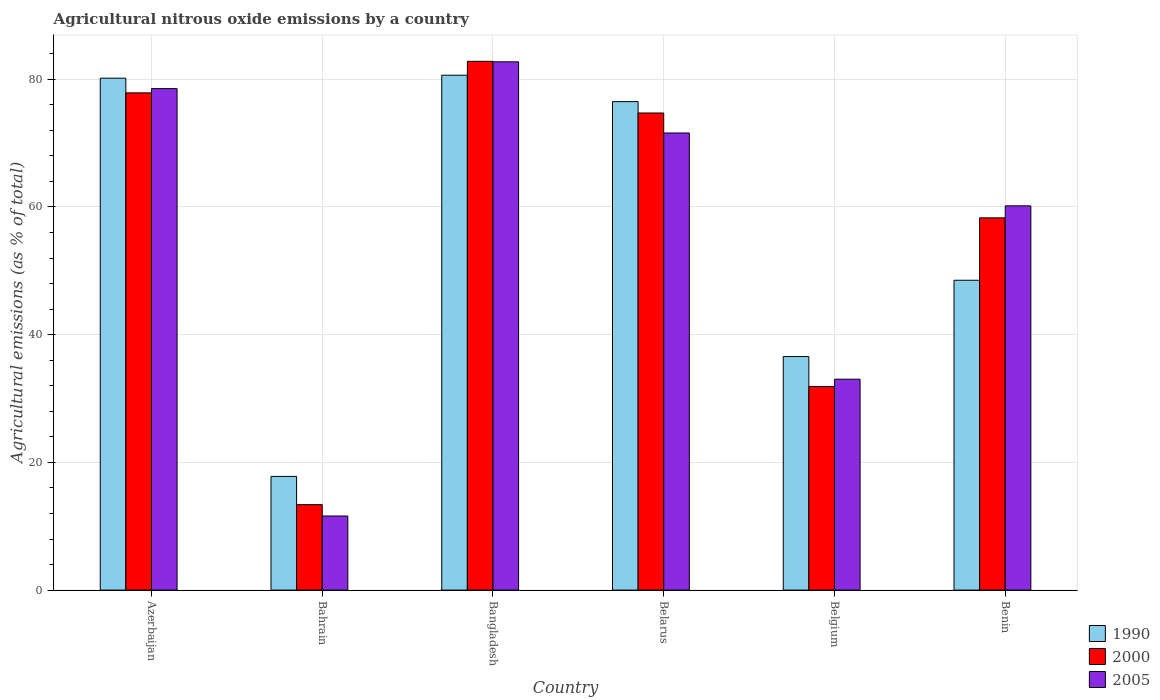How many groups of bars are there?
Make the answer very short. 6. Are the number of bars per tick equal to the number of legend labels?
Your answer should be compact. Yes. How many bars are there on the 3rd tick from the left?
Offer a very short reply. 3. How many bars are there on the 6th tick from the right?
Offer a terse response. 3. What is the label of the 4th group of bars from the left?
Make the answer very short. Belarus. What is the amount of agricultural nitrous oxide emitted in 1990 in Belgium?
Your answer should be compact. 36.57. Across all countries, what is the maximum amount of agricultural nitrous oxide emitted in 2000?
Make the answer very short. 82.81. Across all countries, what is the minimum amount of agricultural nitrous oxide emitted in 2005?
Offer a very short reply. 11.6. In which country was the amount of agricultural nitrous oxide emitted in 1990 maximum?
Make the answer very short. Bangladesh. In which country was the amount of agricultural nitrous oxide emitted in 2000 minimum?
Your answer should be very brief. Bahrain. What is the total amount of agricultural nitrous oxide emitted in 1990 in the graph?
Make the answer very short. 340.2. What is the difference between the amount of agricultural nitrous oxide emitted in 2005 in Bangladesh and that in Benin?
Offer a terse response. 22.55. What is the difference between the amount of agricultural nitrous oxide emitted in 1990 in Benin and the amount of agricultural nitrous oxide emitted in 2000 in Azerbaijan?
Make the answer very short. -29.35. What is the average amount of agricultural nitrous oxide emitted in 2005 per country?
Offer a terse response. 56.28. What is the difference between the amount of agricultural nitrous oxide emitted of/in 2000 and amount of agricultural nitrous oxide emitted of/in 1990 in Benin?
Your response must be concise. 9.77. What is the ratio of the amount of agricultural nitrous oxide emitted in 1990 in Bahrain to that in Belgium?
Offer a terse response. 0.49. Is the amount of agricultural nitrous oxide emitted in 2000 in Belarus less than that in Benin?
Provide a succinct answer. No. Is the difference between the amount of agricultural nitrous oxide emitted in 2000 in Azerbaijan and Benin greater than the difference between the amount of agricultural nitrous oxide emitted in 1990 in Azerbaijan and Benin?
Your response must be concise. No. What is the difference between the highest and the second highest amount of agricultural nitrous oxide emitted in 2000?
Your answer should be compact. 4.94. What is the difference between the highest and the lowest amount of agricultural nitrous oxide emitted in 1990?
Provide a short and direct response. 62.83. What does the 3rd bar from the left in Azerbaijan represents?
Provide a short and direct response. 2005. What does the 2nd bar from the right in Belgium represents?
Give a very brief answer. 2000. Are all the bars in the graph horizontal?
Keep it short and to the point. No. Are the values on the major ticks of Y-axis written in scientific E-notation?
Provide a succinct answer. No. Does the graph contain any zero values?
Provide a succinct answer. No. How are the legend labels stacked?
Provide a short and direct response. Vertical. What is the title of the graph?
Provide a short and direct response. Agricultural nitrous oxide emissions by a country. Does "1994" appear as one of the legend labels in the graph?
Ensure brevity in your answer.  No. What is the label or title of the X-axis?
Provide a short and direct response. Country. What is the label or title of the Y-axis?
Provide a succinct answer. Agricultural emissions (as % of total). What is the Agricultural emissions (as % of total) in 1990 in Azerbaijan?
Your response must be concise. 80.17. What is the Agricultural emissions (as % of total) of 2000 in Azerbaijan?
Offer a very short reply. 77.87. What is the Agricultural emissions (as % of total) in 2005 in Azerbaijan?
Your response must be concise. 78.53. What is the Agricultural emissions (as % of total) of 1990 in Bahrain?
Offer a very short reply. 17.81. What is the Agricultural emissions (as % of total) in 2000 in Bahrain?
Keep it short and to the point. 13.38. What is the Agricultural emissions (as % of total) of 2005 in Bahrain?
Give a very brief answer. 11.6. What is the Agricultural emissions (as % of total) in 1990 in Bangladesh?
Your answer should be compact. 80.63. What is the Agricultural emissions (as % of total) of 2000 in Bangladesh?
Your answer should be very brief. 82.81. What is the Agricultural emissions (as % of total) in 2005 in Bangladesh?
Provide a short and direct response. 82.73. What is the Agricultural emissions (as % of total) of 1990 in Belarus?
Your answer should be compact. 76.5. What is the Agricultural emissions (as % of total) in 2000 in Belarus?
Your answer should be very brief. 74.72. What is the Agricultural emissions (as % of total) of 2005 in Belarus?
Provide a short and direct response. 71.59. What is the Agricultural emissions (as % of total) in 1990 in Belgium?
Your response must be concise. 36.57. What is the Agricultural emissions (as % of total) in 2000 in Belgium?
Keep it short and to the point. 31.88. What is the Agricultural emissions (as % of total) of 2005 in Belgium?
Make the answer very short. 33.03. What is the Agricultural emissions (as % of total) in 1990 in Benin?
Your response must be concise. 48.52. What is the Agricultural emissions (as % of total) in 2000 in Benin?
Your answer should be compact. 58.3. What is the Agricultural emissions (as % of total) of 2005 in Benin?
Make the answer very short. 60.18. Across all countries, what is the maximum Agricultural emissions (as % of total) in 1990?
Keep it short and to the point. 80.63. Across all countries, what is the maximum Agricultural emissions (as % of total) in 2000?
Your answer should be very brief. 82.81. Across all countries, what is the maximum Agricultural emissions (as % of total) in 2005?
Offer a terse response. 82.73. Across all countries, what is the minimum Agricultural emissions (as % of total) in 1990?
Keep it short and to the point. 17.81. Across all countries, what is the minimum Agricultural emissions (as % of total) in 2000?
Make the answer very short. 13.38. Across all countries, what is the minimum Agricultural emissions (as % of total) in 2005?
Make the answer very short. 11.6. What is the total Agricultural emissions (as % of total) of 1990 in the graph?
Offer a very short reply. 340.2. What is the total Agricultural emissions (as % of total) of 2000 in the graph?
Provide a succinct answer. 338.95. What is the total Agricultural emissions (as % of total) of 2005 in the graph?
Your response must be concise. 337.66. What is the difference between the Agricultural emissions (as % of total) in 1990 in Azerbaijan and that in Bahrain?
Your answer should be compact. 62.36. What is the difference between the Agricultural emissions (as % of total) in 2000 in Azerbaijan and that in Bahrain?
Make the answer very short. 64.49. What is the difference between the Agricultural emissions (as % of total) of 2005 in Azerbaijan and that in Bahrain?
Your answer should be very brief. 66.93. What is the difference between the Agricultural emissions (as % of total) in 1990 in Azerbaijan and that in Bangladesh?
Your response must be concise. -0.47. What is the difference between the Agricultural emissions (as % of total) in 2000 in Azerbaijan and that in Bangladesh?
Offer a very short reply. -4.94. What is the difference between the Agricultural emissions (as % of total) of 2005 in Azerbaijan and that in Bangladesh?
Keep it short and to the point. -4.2. What is the difference between the Agricultural emissions (as % of total) of 1990 in Azerbaijan and that in Belarus?
Ensure brevity in your answer.  3.67. What is the difference between the Agricultural emissions (as % of total) in 2000 in Azerbaijan and that in Belarus?
Make the answer very short. 3.16. What is the difference between the Agricultural emissions (as % of total) of 2005 in Azerbaijan and that in Belarus?
Give a very brief answer. 6.94. What is the difference between the Agricultural emissions (as % of total) of 1990 in Azerbaijan and that in Belgium?
Offer a very short reply. 43.59. What is the difference between the Agricultural emissions (as % of total) of 2000 in Azerbaijan and that in Belgium?
Your response must be concise. 45.99. What is the difference between the Agricultural emissions (as % of total) of 2005 in Azerbaijan and that in Belgium?
Provide a short and direct response. 45.5. What is the difference between the Agricultural emissions (as % of total) in 1990 in Azerbaijan and that in Benin?
Keep it short and to the point. 31.64. What is the difference between the Agricultural emissions (as % of total) in 2000 in Azerbaijan and that in Benin?
Keep it short and to the point. 19.57. What is the difference between the Agricultural emissions (as % of total) in 2005 in Azerbaijan and that in Benin?
Ensure brevity in your answer.  18.35. What is the difference between the Agricultural emissions (as % of total) of 1990 in Bahrain and that in Bangladesh?
Your response must be concise. -62.83. What is the difference between the Agricultural emissions (as % of total) of 2000 in Bahrain and that in Bangladesh?
Give a very brief answer. -69.43. What is the difference between the Agricultural emissions (as % of total) in 2005 in Bahrain and that in Bangladesh?
Your answer should be very brief. -71.13. What is the difference between the Agricultural emissions (as % of total) in 1990 in Bahrain and that in Belarus?
Ensure brevity in your answer.  -58.69. What is the difference between the Agricultural emissions (as % of total) of 2000 in Bahrain and that in Belarus?
Ensure brevity in your answer.  -61.34. What is the difference between the Agricultural emissions (as % of total) in 2005 in Bahrain and that in Belarus?
Offer a very short reply. -59.98. What is the difference between the Agricultural emissions (as % of total) of 1990 in Bahrain and that in Belgium?
Make the answer very short. -18.77. What is the difference between the Agricultural emissions (as % of total) of 2000 in Bahrain and that in Belgium?
Provide a short and direct response. -18.5. What is the difference between the Agricultural emissions (as % of total) in 2005 in Bahrain and that in Belgium?
Offer a terse response. -21.43. What is the difference between the Agricultural emissions (as % of total) of 1990 in Bahrain and that in Benin?
Your response must be concise. -30.72. What is the difference between the Agricultural emissions (as % of total) of 2000 in Bahrain and that in Benin?
Offer a very short reply. -44.92. What is the difference between the Agricultural emissions (as % of total) in 2005 in Bahrain and that in Benin?
Ensure brevity in your answer.  -48.57. What is the difference between the Agricultural emissions (as % of total) of 1990 in Bangladesh and that in Belarus?
Give a very brief answer. 4.13. What is the difference between the Agricultural emissions (as % of total) in 2000 in Bangladesh and that in Belarus?
Ensure brevity in your answer.  8.09. What is the difference between the Agricultural emissions (as % of total) of 2005 in Bangladesh and that in Belarus?
Keep it short and to the point. 11.14. What is the difference between the Agricultural emissions (as % of total) of 1990 in Bangladesh and that in Belgium?
Provide a short and direct response. 44.06. What is the difference between the Agricultural emissions (as % of total) in 2000 in Bangladesh and that in Belgium?
Give a very brief answer. 50.93. What is the difference between the Agricultural emissions (as % of total) in 2005 in Bangladesh and that in Belgium?
Give a very brief answer. 49.7. What is the difference between the Agricultural emissions (as % of total) of 1990 in Bangladesh and that in Benin?
Your answer should be very brief. 32.11. What is the difference between the Agricultural emissions (as % of total) in 2000 in Bangladesh and that in Benin?
Make the answer very short. 24.51. What is the difference between the Agricultural emissions (as % of total) in 2005 in Bangladesh and that in Benin?
Keep it short and to the point. 22.55. What is the difference between the Agricultural emissions (as % of total) of 1990 in Belarus and that in Belgium?
Offer a very short reply. 39.93. What is the difference between the Agricultural emissions (as % of total) in 2000 in Belarus and that in Belgium?
Your answer should be compact. 42.83. What is the difference between the Agricultural emissions (as % of total) of 2005 in Belarus and that in Belgium?
Give a very brief answer. 38.56. What is the difference between the Agricultural emissions (as % of total) in 1990 in Belarus and that in Benin?
Your answer should be compact. 27.98. What is the difference between the Agricultural emissions (as % of total) in 2000 in Belarus and that in Benin?
Offer a very short reply. 16.42. What is the difference between the Agricultural emissions (as % of total) of 2005 in Belarus and that in Benin?
Ensure brevity in your answer.  11.41. What is the difference between the Agricultural emissions (as % of total) of 1990 in Belgium and that in Benin?
Your response must be concise. -11.95. What is the difference between the Agricultural emissions (as % of total) of 2000 in Belgium and that in Benin?
Make the answer very short. -26.42. What is the difference between the Agricultural emissions (as % of total) of 2005 in Belgium and that in Benin?
Make the answer very short. -27.15. What is the difference between the Agricultural emissions (as % of total) of 1990 in Azerbaijan and the Agricultural emissions (as % of total) of 2000 in Bahrain?
Keep it short and to the point. 66.79. What is the difference between the Agricultural emissions (as % of total) in 1990 in Azerbaijan and the Agricultural emissions (as % of total) in 2005 in Bahrain?
Your answer should be very brief. 68.56. What is the difference between the Agricultural emissions (as % of total) in 2000 in Azerbaijan and the Agricultural emissions (as % of total) in 2005 in Bahrain?
Your answer should be compact. 66.27. What is the difference between the Agricultural emissions (as % of total) of 1990 in Azerbaijan and the Agricultural emissions (as % of total) of 2000 in Bangladesh?
Give a very brief answer. -2.64. What is the difference between the Agricultural emissions (as % of total) in 1990 in Azerbaijan and the Agricultural emissions (as % of total) in 2005 in Bangladesh?
Offer a very short reply. -2.56. What is the difference between the Agricultural emissions (as % of total) in 2000 in Azerbaijan and the Agricultural emissions (as % of total) in 2005 in Bangladesh?
Offer a terse response. -4.86. What is the difference between the Agricultural emissions (as % of total) of 1990 in Azerbaijan and the Agricultural emissions (as % of total) of 2000 in Belarus?
Your answer should be very brief. 5.45. What is the difference between the Agricultural emissions (as % of total) of 1990 in Azerbaijan and the Agricultural emissions (as % of total) of 2005 in Belarus?
Offer a very short reply. 8.58. What is the difference between the Agricultural emissions (as % of total) of 2000 in Azerbaijan and the Agricultural emissions (as % of total) of 2005 in Belarus?
Provide a succinct answer. 6.28. What is the difference between the Agricultural emissions (as % of total) of 1990 in Azerbaijan and the Agricultural emissions (as % of total) of 2000 in Belgium?
Offer a terse response. 48.29. What is the difference between the Agricultural emissions (as % of total) of 1990 in Azerbaijan and the Agricultural emissions (as % of total) of 2005 in Belgium?
Provide a succinct answer. 47.14. What is the difference between the Agricultural emissions (as % of total) of 2000 in Azerbaijan and the Agricultural emissions (as % of total) of 2005 in Belgium?
Make the answer very short. 44.84. What is the difference between the Agricultural emissions (as % of total) of 1990 in Azerbaijan and the Agricultural emissions (as % of total) of 2000 in Benin?
Give a very brief answer. 21.87. What is the difference between the Agricultural emissions (as % of total) of 1990 in Azerbaijan and the Agricultural emissions (as % of total) of 2005 in Benin?
Your response must be concise. 19.99. What is the difference between the Agricultural emissions (as % of total) in 2000 in Azerbaijan and the Agricultural emissions (as % of total) in 2005 in Benin?
Provide a short and direct response. 17.69. What is the difference between the Agricultural emissions (as % of total) of 1990 in Bahrain and the Agricultural emissions (as % of total) of 2000 in Bangladesh?
Your response must be concise. -65. What is the difference between the Agricultural emissions (as % of total) of 1990 in Bahrain and the Agricultural emissions (as % of total) of 2005 in Bangladesh?
Offer a very short reply. -64.92. What is the difference between the Agricultural emissions (as % of total) in 2000 in Bahrain and the Agricultural emissions (as % of total) in 2005 in Bangladesh?
Provide a short and direct response. -69.35. What is the difference between the Agricultural emissions (as % of total) in 1990 in Bahrain and the Agricultural emissions (as % of total) in 2000 in Belarus?
Ensure brevity in your answer.  -56.91. What is the difference between the Agricultural emissions (as % of total) of 1990 in Bahrain and the Agricultural emissions (as % of total) of 2005 in Belarus?
Keep it short and to the point. -53.78. What is the difference between the Agricultural emissions (as % of total) in 2000 in Bahrain and the Agricultural emissions (as % of total) in 2005 in Belarus?
Your response must be concise. -58.21. What is the difference between the Agricultural emissions (as % of total) of 1990 in Bahrain and the Agricultural emissions (as % of total) of 2000 in Belgium?
Make the answer very short. -14.07. What is the difference between the Agricultural emissions (as % of total) of 1990 in Bahrain and the Agricultural emissions (as % of total) of 2005 in Belgium?
Provide a short and direct response. -15.22. What is the difference between the Agricultural emissions (as % of total) of 2000 in Bahrain and the Agricultural emissions (as % of total) of 2005 in Belgium?
Give a very brief answer. -19.65. What is the difference between the Agricultural emissions (as % of total) in 1990 in Bahrain and the Agricultural emissions (as % of total) in 2000 in Benin?
Your answer should be compact. -40.49. What is the difference between the Agricultural emissions (as % of total) of 1990 in Bahrain and the Agricultural emissions (as % of total) of 2005 in Benin?
Provide a short and direct response. -42.37. What is the difference between the Agricultural emissions (as % of total) in 2000 in Bahrain and the Agricultural emissions (as % of total) in 2005 in Benin?
Your answer should be compact. -46.8. What is the difference between the Agricultural emissions (as % of total) in 1990 in Bangladesh and the Agricultural emissions (as % of total) in 2000 in Belarus?
Offer a terse response. 5.92. What is the difference between the Agricultural emissions (as % of total) of 1990 in Bangladesh and the Agricultural emissions (as % of total) of 2005 in Belarus?
Give a very brief answer. 9.04. What is the difference between the Agricultural emissions (as % of total) of 2000 in Bangladesh and the Agricultural emissions (as % of total) of 2005 in Belarus?
Offer a terse response. 11.22. What is the difference between the Agricultural emissions (as % of total) of 1990 in Bangladesh and the Agricultural emissions (as % of total) of 2000 in Belgium?
Ensure brevity in your answer.  48.75. What is the difference between the Agricultural emissions (as % of total) of 1990 in Bangladesh and the Agricultural emissions (as % of total) of 2005 in Belgium?
Offer a very short reply. 47.6. What is the difference between the Agricultural emissions (as % of total) of 2000 in Bangladesh and the Agricultural emissions (as % of total) of 2005 in Belgium?
Keep it short and to the point. 49.78. What is the difference between the Agricultural emissions (as % of total) of 1990 in Bangladesh and the Agricultural emissions (as % of total) of 2000 in Benin?
Provide a succinct answer. 22.34. What is the difference between the Agricultural emissions (as % of total) of 1990 in Bangladesh and the Agricultural emissions (as % of total) of 2005 in Benin?
Make the answer very short. 20.46. What is the difference between the Agricultural emissions (as % of total) of 2000 in Bangladesh and the Agricultural emissions (as % of total) of 2005 in Benin?
Ensure brevity in your answer.  22.63. What is the difference between the Agricultural emissions (as % of total) of 1990 in Belarus and the Agricultural emissions (as % of total) of 2000 in Belgium?
Your answer should be compact. 44.62. What is the difference between the Agricultural emissions (as % of total) in 1990 in Belarus and the Agricultural emissions (as % of total) in 2005 in Belgium?
Your answer should be compact. 43.47. What is the difference between the Agricultural emissions (as % of total) of 2000 in Belarus and the Agricultural emissions (as % of total) of 2005 in Belgium?
Offer a very short reply. 41.69. What is the difference between the Agricultural emissions (as % of total) of 1990 in Belarus and the Agricultural emissions (as % of total) of 2000 in Benin?
Offer a very short reply. 18.2. What is the difference between the Agricultural emissions (as % of total) of 1990 in Belarus and the Agricultural emissions (as % of total) of 2005 in Benin?
Your answer should be compact. 16.32. What is the difference between the Agricultural emissions (as % of total) in 2000 in Belarus and the Agricultural emissions (as % of total) in 2005 in Benin?
Ensure brevity in your answer.  14.54. What is the difference between the Agricultural emissions (as % of total) of 1990 in Belgium and the Agricultural emissions (as % of total) of 2000 in Benin?
Your response must be concise. -21.72. What is the difference between the Agricultural emissions (as % of total) in 1990 in Belgium and the Agricultural emissions (as % of total) in 2005 in Benin?
Provide a succinct answer. -23.6. What is the difference between the Agricultural emissions (as % of total) of 2000 in Belgium and the Agricultural emissions (as % of total) of 2005 in Benin?
Make the answer very short. -28.3. What is the average Agricultural emissions (as % of total) in 1990 per country?
Provide a succinct answer. 56.7. What is the average Agricultural emissions (as % of total) in 2000 per country?
Provide a short and direct response. 56.49. What is the average Agricultural emissions (as % of total) in 2005 per country?
Your answer should be very brief. 56.28. What is the difference between the Agricultural emissions (as % of total) in 1990 and Agricultural emissions (as % of total) in 2000 in Azerbaijan?
Ensure brevity in your answer.  2.3. What is the difference between the Agricultural emissions (as % of total) in 1990 and Agricultural emissions (as % of total) in 2005 in Azerbaijan?
Offer a terse response. 1.64. What is the difference between the Agricultural emissions (as % of total) of 2000 and Agricultural emissions (as % of total) of 2005 in Azerbaijan?
Your answer should be very brief. -0.66. What is the difference between the Agricultural emissions (as % of total) in 1990 and Agricultural emissions (as % of total) in 2000 in Bahrain?
Keep it short and to the point. 4.43. What is the difference between the Agricultural emissions (as % of total) in 1990 and Agricultural emissions (as % of total) in 2005 in Bahrain?
Make the answer very short. 6.2. What is the difference between the Agricultural emissions (as % of total) of 2000 and Agricultural emissions (as % of total) of 2005 in Bahrain?
Provide a short and direct response. 1.78. What is the difference between the Agricultural emissions (as % of total) of 1990 and Agricultural emissions (as % of total) of 2000 in Bangladesh?
Your answer should be very brief. -2.18. What is the difference between the Agricultural emissions (as % of total) of 1990 and Agricultural emissions (as % of total) of 2005 in Bangladesh?
Provide a short and direct response. -2.1. What is the difference between the Agricultural emissions (as % of total) in 2000 and Agricultural emissions (as % of total) in 2005 in Bangladesh?
Provide a succinct answer. 0.08. What is the difference between the Agricultural emissions (as % of total) in 1990 and Agricultural emissions (as % of total) in 2000 in Belarus?
Keep it short and to the point. 1.78. What is the difference between the Agricultural emissions (as % of total) of 1990 and Agricultural emissions (as % of total) of 2005 in Belarus?
Provide a succinct answer. 4.91. What is the difference between the Agricultural emissions (as % of total) of 2000 and Agricultural emissions (as % of total) of 2005 in Belarus?
Provide a succinct answer. 3.13. What is the difference between the Agricultural emissions (as % of total) in 1990 and Agricultural emissions (as % of total) in 2000 in Belgium?
Your answer should be compact. 4.69. What is the difference between the Agricultural emissions (as % of total) in 1990 and Agricultural emissions (as % of total) in 2005 in Belgium?
Provide a succinct answer. 3.54. What is the difference between the Agricultural emissions (as % of total) in 2000 and Agricultural emissions (as % of total) in 2005 in Belgium?
Your response must be concise. -1.15. What is the difference between the Agricultural emissions (as % of total) of 1990 and Agricultural emissions (as % of total) of 2000 in Benin?
Ensure brevity in your answer.  -9.77. What is the difference between the Agricultural emissions (as % of total) in 1990 and Agricultural emissions (as % of total) in 2005 in Benin?
Keep it short and to the point. -11.65. What is the difference between the Agricultural emissions (as % of total) of 2000 and Agricultural emissions (as % of total) of 2005 in Benin?
Provide a succinct answer. -1.88. What is the ratio of the Agricultural emissions (as % of total) of 1990 in Azerbaijan to that in Bahrain?
Give a very brief answer. 4.5. What is the ratio of the Agricultural emissions (as % of total) of 2000 in Azerbaijan to that in Bahrain?
Provide a short and direct response. 5.82. What is the ratio of the Agricultural emissions (as % of total) in 2005 in Azerbaijan to that in Bahrain?
Ensure brevity in your answer.  6.77. What is the ratio of the Agricultural emissions (as % of total) in 2000 in Azerbaijan to that in Bangladesh?
Keep it short and to the point. 0.94. What is the ratio of the Agricultural emissions (as % of total) in 2005 in Azerbaijan to that in Bangladesh?
Ensure brevity in your answer.  0.95. What is the ratio of the Agricultural emissions (as % of total) in 1990 in Azerbaijan to that in Belarus?
Your response must be concise. 1.05. What is the ratio of the Agricultural emissions (as % of total) of 2000 in Azerbaijan to that in Belarus?
Your response must be concise. 1.04. What is the ratio of the Agricultural emissions (as % of total) of 2005 in Azerbaijan to that in Belarus?
Provide a short and direct response. 1.1. What is the ratio of the Agricultural emissions (as % of total) in 1990 in Azerbaijan to that in Belgium?
Provide a succinct answer. 2.19. What is the ratio of the Agricultural emissions (as % of total) of 2000 in Azerbaijan to that in Belgium?
Give a very brief answer. 2.44. What is the ratio of the Agricultural emissions (as % of total) of 2005 in Azerbaijan to that in Belgium?
Ensure brevity in your answer.  2.38. What is the ratio of the Agricultural emissions (as % of total) in 1990 in Azerbaijan to that in Benin?
Keep it short and to the point. 1.65. What is the ratio of the Agricultural emissions (as % of total) in 2000 in Azerbaijan to that in Benin?
Your answer should be compact. 1.34. What is the ratio of the Agricultural emissions (as % of total) of 2005 in Azerbaijan to that in Benin?
Your answer should be very brief. 1.3. What is the ratio of the Agricultural emissions (as % of total) of 1990 in Bahrain to that in Bangladesh?
Offer a very short reply. 0.22. What is the ratio of the Agricultural emissions (as % of total) of 2000 in Bahrain to that in Bangladesh?
Your response must be concise. 0.16. What is the ratio of the Agricultural emissions (as % of total) in 2005 in Bahrain to that in Bangladesh?
Your answer should be compact. 0.14. What is the ratio of the Agricultural emissions (as % of total) in 1990 in Bahrain to that in Belarus?
Offer a terse response. 0.23. What is the ratio of the Agricultural emissions (as % of total) of 2000 in Bahrain to that in Belarus?
Your answer should be very brief. 0.18. What is the ratio of the Agricultural emissions (as % of total) of 2005 in Bahrain to that in Belarus?
Offer a terse response. 0.16. What is the ratio of the Agricultural emissions (as % of total) in 1990 in Bahrain to that in Belgium?
Provide a short and direct response. 0.49. What is the ratio of the Agricultural emissions (as % of total) of 2000 in Bahrain to that in Belgium?
Your answer should be compact. 0.42. What is the ratio of the Agricultural emissions (as % of total) of 2005 in Bahrain to that in Belgium?
Provide a succinct answer. 0.35. What is the ratio of the Agricultural emissions (as % of total) of 1990 in Bahrain to that in Benin?
Your answer should be very brief. 0.37. What is the ratio of the Agricultural emissions (as % of total) in 2000 in Bahrain to that in Benin?
Keep it short and to the point. 0.23. What is the ratio of the Agricultural emissions (as % of total) of 2005 in Bahrain to that in Benin?
Your answer should be compact. 0.19. What is the ratio of the Agricultural emissions (as % of total) of 1990 in Bangladesh to that in Belarus?
Provide a succinct answer. 1.05. What is the ratio of the Agricultural emissions (as % of total) in 2000 in Bangladesh to that in Belarus?
Ensure brevity in your answer.  1.11. What is the ratio of the Agricultural emissions (as % of total) of 2005 in Bangladesh to that in Belarus?
Keep it short and to the point. 1.16. What is the ratio of the Agricultural emissions (as % of total) in 1990 in Bangladesh to that in Belgium?
Offer a very short reply. 2.2. What is the ratio of the Agricultural emissions (as % of total) of 2000 in Bangladesh to that in Belgium?
Your response must be concise. 2.6. What is the ratio of the Agricultural emissions (as % of total) in 2005 in Bangladesh to that in Belgium?
Keep it short and to the point. 2.5. What is the ratio of the Agricultural emissions (as % of total) of 1990 in Bangladesh to that in Benin?
Provide a succinct answer. 1.66. What is the ratio of the Agricultural emissions (as % of total) of 2000 in Bangladesh to that in Benin?
Provide a succinct answer. 1.42. What is the ratio of the Agricultural emissions (as % of total) in 2005 in Bangladesh to that in Benin?
Your answer should be compact. 1.37. What is the ratio of the Agricultural emissions (as % of total) of 1990 in Belarus to that in Belgium?
Your response must be concise. 2.09. What is the ratio of the Agricultural emissions (as % of total) in 2000 in Belarus to that in Belgium?
Offer a terse response. 2.34. What is the ratio of the Agricultural emissions (as % of total) in 2005 in Belarus to that in Belgium?
Keep it short and to the point. 2.17. What is the ratio of the Agricultural emissions (as % of total) in 1990 in Belarus to that in Benin?
Offer a terse response. 1.58. What is the ratio of the Agricultural emissions (as % of total) of 2000 in Belarus to that in Benin?
Keep it short and to the point. 1.28. What is the ratio of the Agricultural emissions (as % of total) in 2005 in Belarus to that in Benin?
Make the answer very short. 1.19. What is the ratio of the Agricultural emissions (as % of total) in 1990 in Belgium to that in Benin?
Ensure brevity in your answer.  0.75. What is the ratio of the Agricultural emissions (as % of total) in 2000 in Belgium to that in Benin?
Keep it short and to the point. 0.55. What is the ratio of the Agricultural emissions (as % of total) of 2005 in Belgium to that in Benin?
Your response must be concise. 0.55. What is the difference between the highest and the second highest Agricultural emissions (as % of total) in 1990?
Make the answer very short. 0.47. What is the difference between the highest and the second highest Agricultural emissions (as % of total) in 2000?
Your answer should be compact. 4.94. What is the difference between the highest and the second highest Agricultural emissions (as % of total) in 2005?
Make the answer very short. 4.2. What is the difference between the highest and the lowest Agricultural emissions (as % of total) of 1990?
Offer a very short reply. 62.83. What is the difference between the highest and the lowest Agricultural emissions (as % of total) of 2000?
Offer a very short reply. 69.43. What is the difference between the highest and the lowest Agricultural emissions (as % of total) in 2005?
Keep it short and to the point. 71.13. 